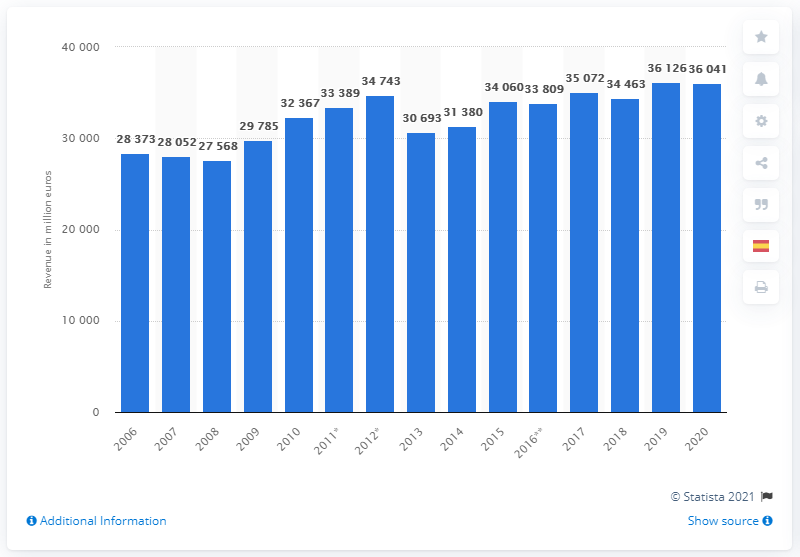Outline some significant characteristics in this image. In 2006, Sanofi's revenues were 28.4 billion euros. In 2020, Sanofi generated a revenue of 36,041... Sanofi's revenue in 2006 was 28,373. 